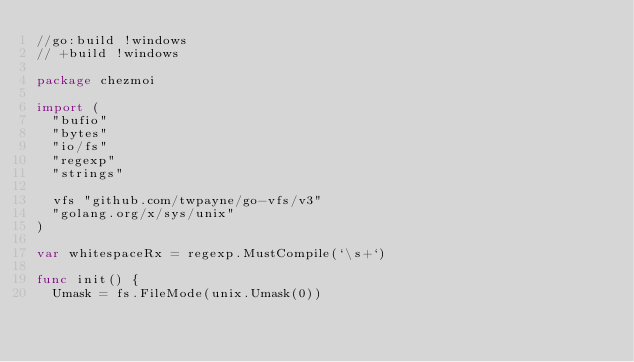Convert code to text. <code><loc_0><loc_0><loc_500><loc_500><_Go_>//go:build !windows
// +build !windows

package chezmoi

import (
	"bufio"
	"bytes"
	"io/fs"
	"regexp"
	"strings"

	vfs "github.com/twpayne/go-vfs/v3"
	"golang.org/x/sys/unix"
)

var whitespaceRx = regexp.MustCompile(`\s+`)

func init() {
	Umask = fs.FileMode(unix.Umask(0))</code> 